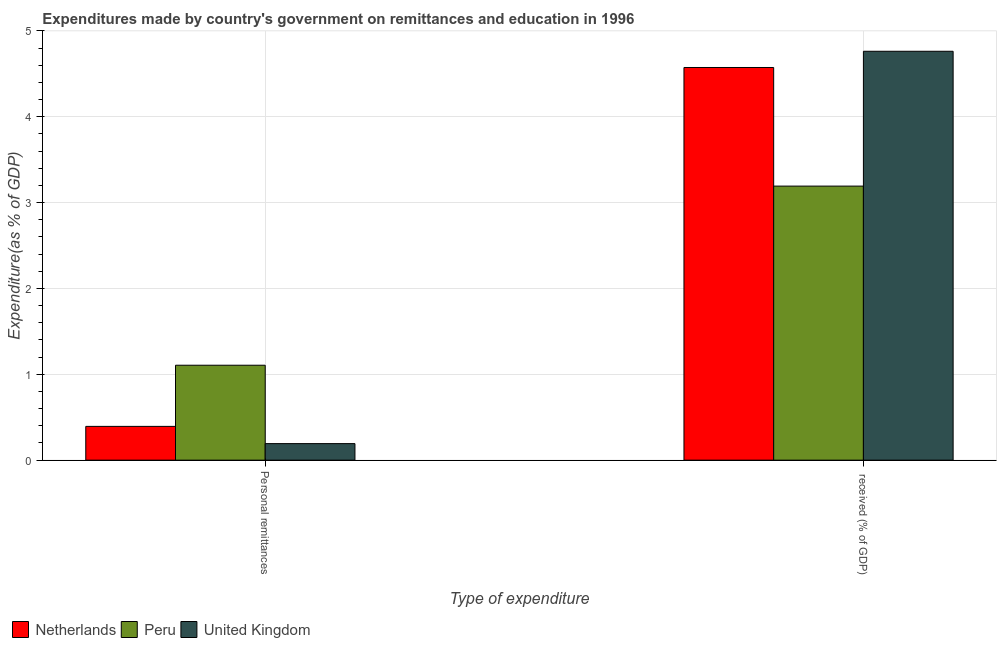How many groups of bars are there?
Make the answer very short. 2. How many bars are there on the 2nd tick from the left?
Provide a succinct answer. 3. What is the label of the 1st group of bars from the left?
Make the answer very short. Personal remittances. What is the expenditure in personal remittances in Peru?
Offer a very short reply. 1.11. Across all countries, what is the maximum expenditure in education?
Your response must be concise. 4.76. Across all countries, what is the minimum expenditure in education?
Your answer should be compact. 3.19. In which country was the expenditure in personal remittances minimum?
Provide a short and direct response. United Kingdom. What is the total expenditure in personal remittances in the graph?
Your answer should be compact. 1.69. What is the difference between the expenditure in personal remittances in Peru and that in United Kingdom?
Offer a terse response. 0.91. What is the difference between the expenditure in education in Peru and the expenditure in personal remittances in United Kingdom?
Give a very brief answer. 3. What is the average expenditure in education per country?
Give a very brief answer. 4.18. What is the difference between the expenditure in education and expenditure in personal remittances in United Kingdom?
Your answer should be very brief. 4.57. What is the ratio of the expenditure in personal remittances in Netherlands to that in United Kingdom?
Keep it short and to the point. 2.04. Is the expenditure in personal remittances in Netherlands less than that in Peru?
Ensure brevity in your answer.  Yes. How many bars are there?
Your answer should be compact. 6. How many countries are there in the graph?
Provide a succinct answer. 3. Does the graph contain any zero values?
Your answer should be compact. No. Where does the legend appear in the graph?
Give a very brief answer. Bottom left. How are the legend labels stacked?
Ensure brevity in your answer.  Horizontal. What is the title of the graph?
Provide a succinct answer. Expenditures made by country's government on remittances and education in 1996. Does "Dominican Republic" appear as one of the legend labels in the graph?
Provide a succinct answer. No. What is the label or title of the X-axis?
Provide a succinct answer. Type of expenditure. What is the label or title of the Y-axis?
Give a very brief answer. Expenditure(as % of GDP). What is the Expenditure(as % of GDP) in Netherlands in Personal remittances?
Your answer should be very brief. 0.39. What is the Expenditure(as % of GDP) of Peru in Personal remittances?
Your answer should be very brief. 1.11. What is the Expenditure(as % of GDP) of United Kingdom in Personal remittances?
Provide a succinct answer. 0.19. What is the Expenditure(as % of GDP) of Netherlands in  received (% of GDP)?
Offer a terse response. 4.57. What is the Expenditure(as % of GDP) of Peru in  received (% of GDP)?
Ensure brevity in your answer.  3.19. What is the Expenditure(as % of GDP) of United Kingdom in  received (% of GDP)?
Offer a very short reply. 4.76. Across all Type of expenditure, what is the maximum Expenditure(as % of GDP) of Netherlands?
Give a very brief answer. 4.57. Across all Type of expenditure, what is the maximum Expenditure(as % of GDP) of Peru?
Provide a short and direct response. 3.19. Across all Type of expenditure, what is the maximum Expenditure(as % of GDP) of United Kingdom?
Keep it short and to the point. 4.76. Across all Type of expenditure, what is the minimum Expenditure(as % of GDP) of Netherlands?
Provide a succinct answer. 0.39. Across all Type of expenditure, what is the minimum Expenditure(as % of GDP) of Peru?
Make the answer very short. 1.11. Across all Type of expenditure, what is the minimum Expenditure(as % of GDP) of United Kingdom?
Offer a very short reply. 0.19. What is the total Expenditure(as % of GDP) of Netherlands in the graph?
Your response must be concise. 4.97. What is the total Expenditure(as % of GDP) of Peru in the graph?
Ensure brevity in your answer.  4.3. What is the total Expenditure(as % of GDP) of United Kingdom in the graph?
Keep it short and to the point. 4.96. What is the difference between the Expenditure(as % of GDP) in Netherlands in Personal remittances and that in  received (% of GDP)?
Ensure brevity in your answer.  -4.18. What is the difference between the Expenditure(as % of GDP) in Peru in Personal remittances and that in  received (% of GDP)?
Your response must be concise. -2.09. What is the difference between the Expenditure(as % of GDP) of United Kingdom in Personal remittances and that in  received (% of GDP)?
Provide a succinct answer. -4.57. What is the difference between the Expenditure(as % of GDP) in Netherlands in Personal remittances and the Expenditure(as % of GDP) in Peru in  received (% of GDP)?
Ensure brevity in your answer.  -2.8. What is the difference between the Expenditure(as % of GDP) in Netherlands in Personal remittances and the Expenditure(as % of GDP) in United Kingdom in  received (% of GDP)?
Provide a succinct answer. -4.37. What is the difference between the Expenditure(as % of GDP) of Peru in Personal remittances and the Expenditure(as % of GDP) of United Kingdom in  received (% of GDP)?
Give a very brief answer. -3.66. What is the average Expenditure(as % of GDP) of Netherlands per Type of expenditure?
Keep it short and to the point. 2.48. What is the average Expenditure(as % of GDP) of Peru per Type of expenditure?
Give a very brief answer. 2.15. What is the average Expenditure(as % of GDP) of United Kingdom per Type of expenditure?
Ensure brevity in your answer.  2.48. What is the difference between the Expenditure(as % of GDP) in Netherlands and Expenditure(as % of GDP) in Peru in Personal remittances?
Keep it short and to the point. -0.71. What is the difference between the Expenditure(as % of GDP) in Netherlands and Expenditure(as % of GDP) in United Kingdom in Personal remittances?
Make the answer very short. 0.2. What is the difference between the Expenditure(as % of GDP) in Peru and Expenditure(as % of GDP) in United Kingdom in Personal remittances?
Offer a very short reply. 0.91. What is the difference between the Expenditure(as % of GDP) in Netherlands and Expenditure(as % of GDP) in Peru in  received (% of GDP)?
Provide a succinct answer. 1.38. What is the difference between the Expenditure(as % of GDP) in Netherlands and Expenditure(as % of GDP) in United Kingdom in  received (% of GDP)?
Your answer should be compact. -0.19. What is the difference between the Expenditure(as % of GDP) in Peru and Expenditure(as % of GDP) in United Kingdom in  received (% of GDP)?
Your response must be concise. -1.57. What is the ratio of the Expenditure(as % of GDP) of Netherlands in Personal remittances to that in  received (% of GDP)?
Your response must be concise. 0.09. What is the ratio of the Expenditure(as % of GDP) in Peru in Personal remittances to that in  received (% of GDP)?
Your response must be concise. 0.35. What is the ratio of the Expenditure(as % of GDP) of United Kingdom in Personal remittances to that in  received (% of GDP)?
Ensure brevity in your answer.  0.04. What is the difference between the highest and the second highest Expenditure(as % of GDP) of Netherlands?
Offer a terse response. 4.18. What is the difference between the highest and the second highest Expenditure(as % of GDP) in Peru?
Make the answer very short. 2.09. What is the difference between the highest and the second highest Expenditure(as % of GDP) of United Kingdom?
Provide a succinct answer. 4.57. What is the difference between the highest and the lowest Expenditure(as % of GDP) in Netherlands?
Offer a very short reply. 4.18. What is the difference between the highest and the lowest Expenditure(as % of GDP) of Peru?
Offer a terse response. 2.09. What is the difference between the highest and the lowest Expenditure(as % of GDP) in United Kingdom?
Offer a terse response. 4.57. 